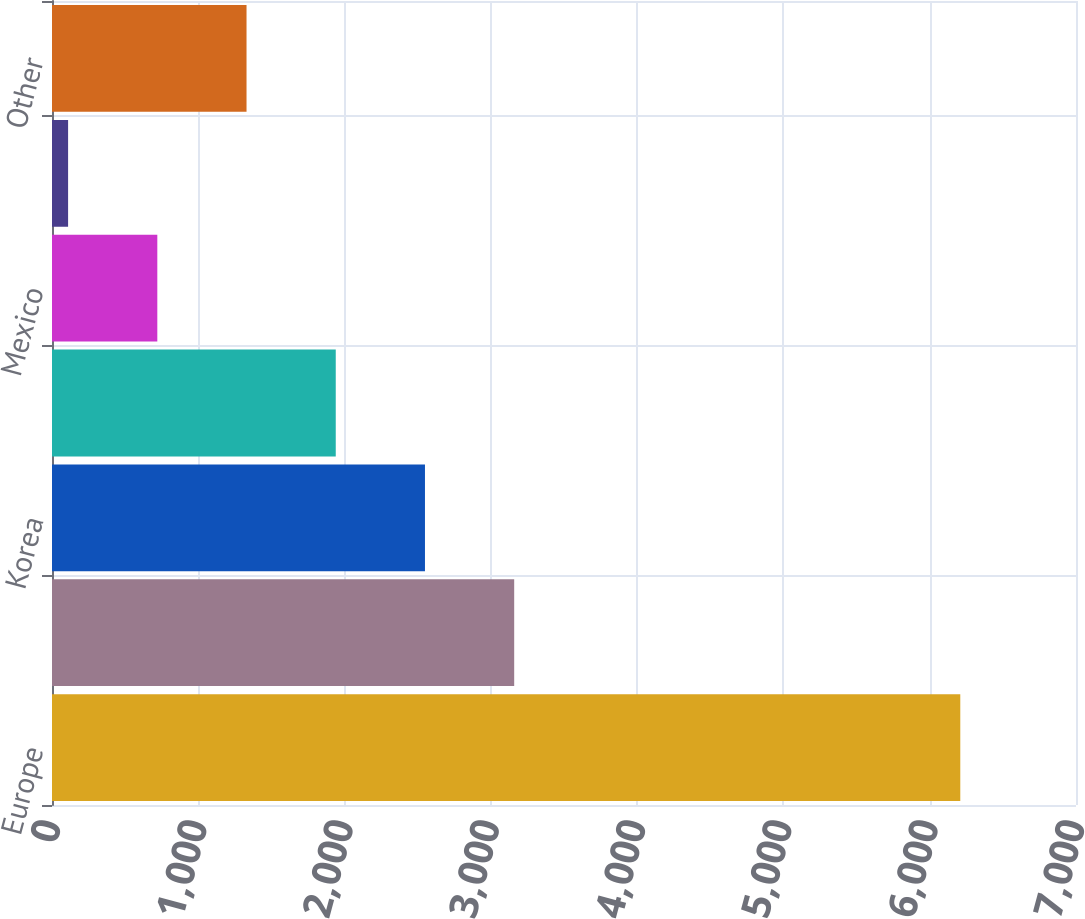<chart> <loc_0><loc_0><loc_500><loc_500><bar_chart><fcel>Europe<fcel>Japan<fcel>Korea<fcel>Indonesia<fcel>Mexico<fcel>Australia<fcel>Other<nl><fcel>6209<fcel>3159.5<fcel>2549.6<fcel>1939.7<fcel>719.9<fcel>110<fcel>1329.8<nl></chart> 